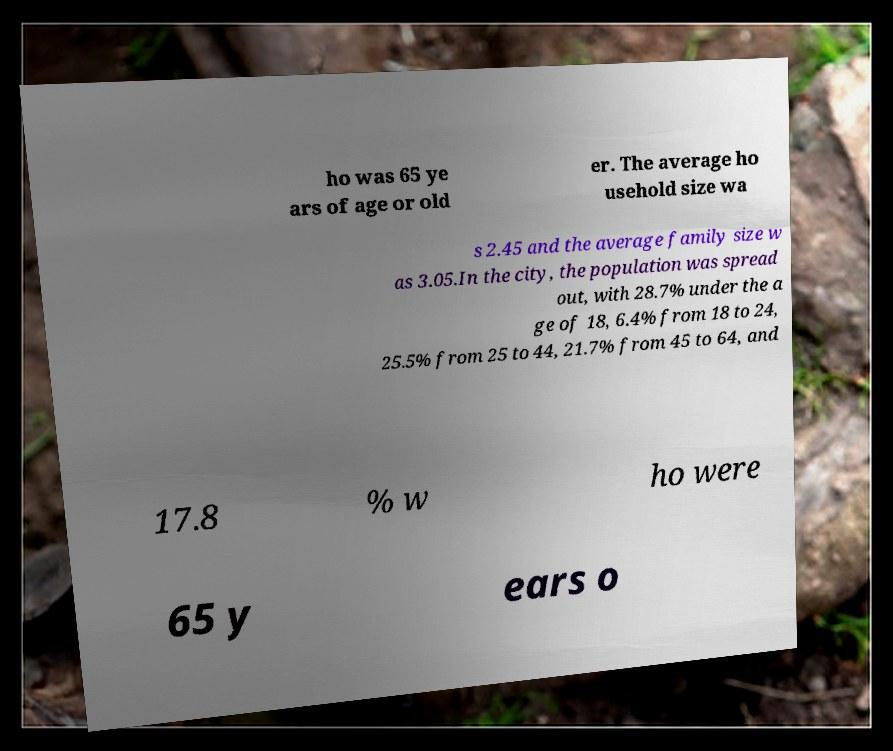For documentation purposes, I need the text within this image transcribed. Could you provide that? ho was 65 ye ars of age or old er. The average ho usehold size wa s 2.45 and the average family size w as 3.05.In the city, the population was spread out, with 28.7% under the a ge of 18, 6.4% from 18 to 24, 25.5% from 25 to 44, 21.7% from 45 to 64, and 17.8 % w ho were 65 y ears o 